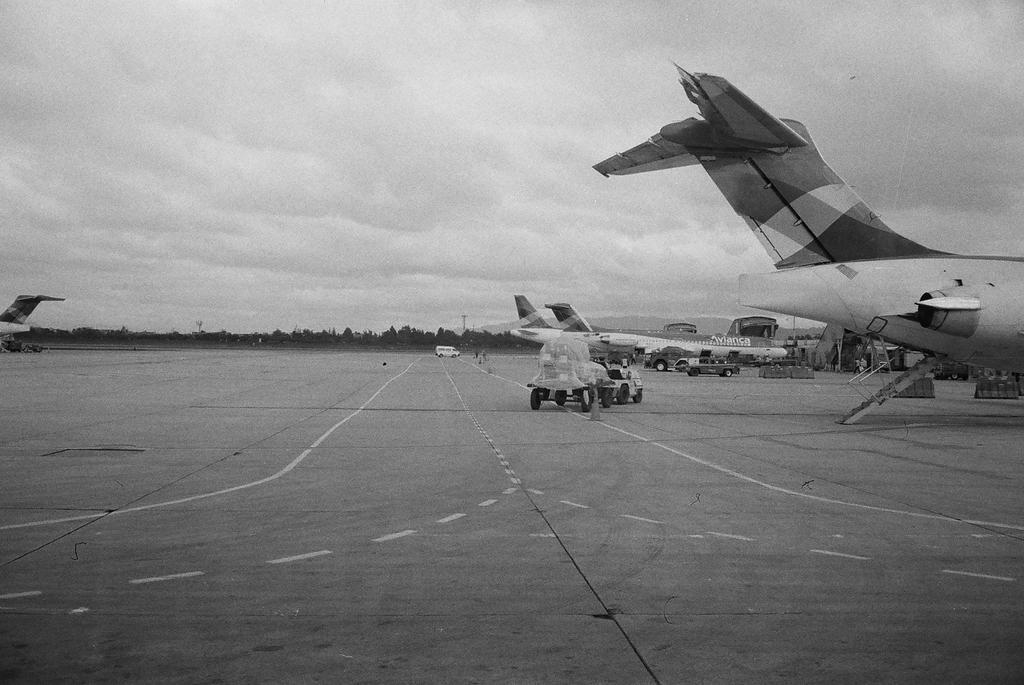In one or two sentences, can you explain what this image depicts? In this picture we can see can see airplanes, vehicles on the ground, some objects and in the background we can see trees and the sky with clouds. 